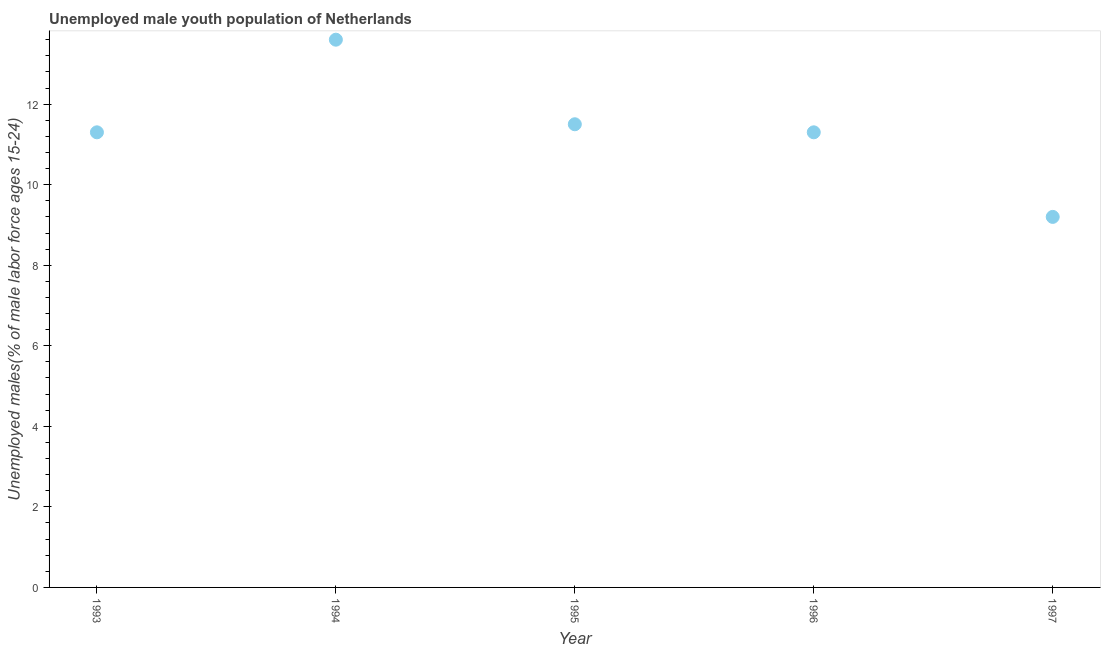Across all years, what is the maximum unemployed male youth?
Offer a very short reply. 13.6. Across all years, what is the minimum unemployed male youth?
Offer a terse response. 9.2. What is the sum of the unemployed male youth?
Your answer should be compact. 56.9. What is the difference between the unemployed male youth in 1993 and 1997?
Ensure brevity in your answer.  2.1. What is the average unemployed male youth per year?
Provide a short and direct response. 11.38. What is the median unemployed male youth?
Your response must be concise. 11.3. What is the ratio of the unemployed male youth in 1994 to that in 1996?
Keep it short and to the point. 1.2. Is the difference between the unemployed male youth in 1993 and 1994 greater than the difference between any two years?
Keep it short and to the point. No. What is the difference between the highest and the second highest unemployed male youth?
Offer a terse response. 2.1. What is the difference between the highest and the lowest unemployed male youth?
Your answer should be very brief. 4.4. How many dotlines are there?
Make the answer very short. 1. How many years are there in the graph?
Provide a succinct answer. 5. What is the difference between two consecutive major ticks on the Y-axis?
Make the answer very short. 2. Are the values on the major ticks of Y-axis written in scientific E-notation?
Provide a short and direct response. No. Does the graph contain any zero values?
Your response must be concise. No. What is the title of the graph?
Offer a very short reply. Unemployed male youth population of Netherlands. What is the label or title of the X-axis?
Your answer should be very brief. Year. What is the label or title of the Y-axis?
Ensure brevity in your answer.  Unemployed males(% of male labor force ages 15-24). What is the Unemployed males(% of male labor force ages 15-24) in 1993?
Your response must be concise. 11.3. What is the Unemployed males(% of male labor force ages 15-24) in 1994?
Offer a terse response. 13.6. What is the Unemployed males(% of male labor force ages 15-24) in 1995?
Your answer should be compact. 11.5. What is the Unemployed males(% of male labor force ages 15-24) in 1996?
Keep it short and to the point. 11.3. What is the Unemployed males(% of male labor force ages 15-24) in 1997?
Your response must be concise. 9.2. What is the difference between the Unemployed males(% of male labor force ages 15-24) in 1993 and 1995?
Provide a succinct answer. -0.2. What is the difference between the Unemployed males(% of male labor force ages 15-24) in 1993 and 1997?
Provide a succinct answer. 2.1. What is the ratio of the Unemployed males(% of male labor force ages 15-24) in 1993 to that in 1994?
Your answer should be very brief. 0.83. What is the ratio of the Unemployed males(% of male labor force ages 15-24) in 1993 to that in 1995?
Your answer should be very brief. 0.98. What is the ratio of the Unemployed males(% of male labor force ages 15-24) in 1993 to that in 1996?
Keep it short and to the point. 1. What is the ratio of the Unemployed males(% of male labor force ages 15-24) in 1993 to that in 1997?
Your answer should be compact. 1.23. What is the ratio of the Unemployed males(% of male labor force ages 15-24) in 1994 to that in 1995?
Give a very brief answer. 1.18. What is the ratio of the Unemployed males(% of male labor force ages 15-24) in 1994 to that in 1996?
Provide a short and direct response. 1.2. What is the ratio of the Unemployed males(% of male labor force ages 15-24) in 1994 to that in 1997?
Your answer should be very brief. 1.48. What is the ratio of the Unemployed males(% of male labor force ages 15-24) in 1995 to that in 1996?
Keep it short and to the point. 1.02. What is the ratio of the Unemployed males(% of male labor force ages 15-24) in 1995 to that in 1997?
Your response must be concise. 1.25. What is the ratio of the Unemployed males(% of male labor force ages 15-24) in 1996 to that in 1997?
Keep it short and to the point. 1.23. 